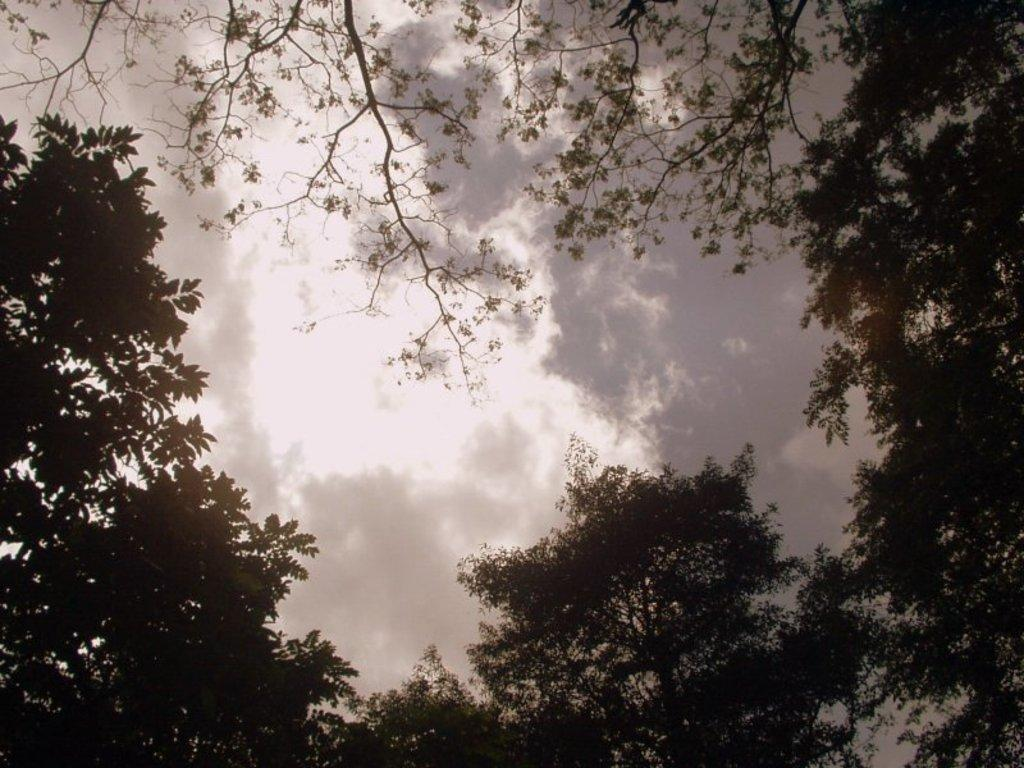What type of vegetation can be seen in the image? There are trees in the image. What part of the natural environment is visible in the image? The sky is visible in the background of the image. Can you tell me how many people are on vacation in the image? There is no information about people or vacations in the image; it only features trees and the sky. 